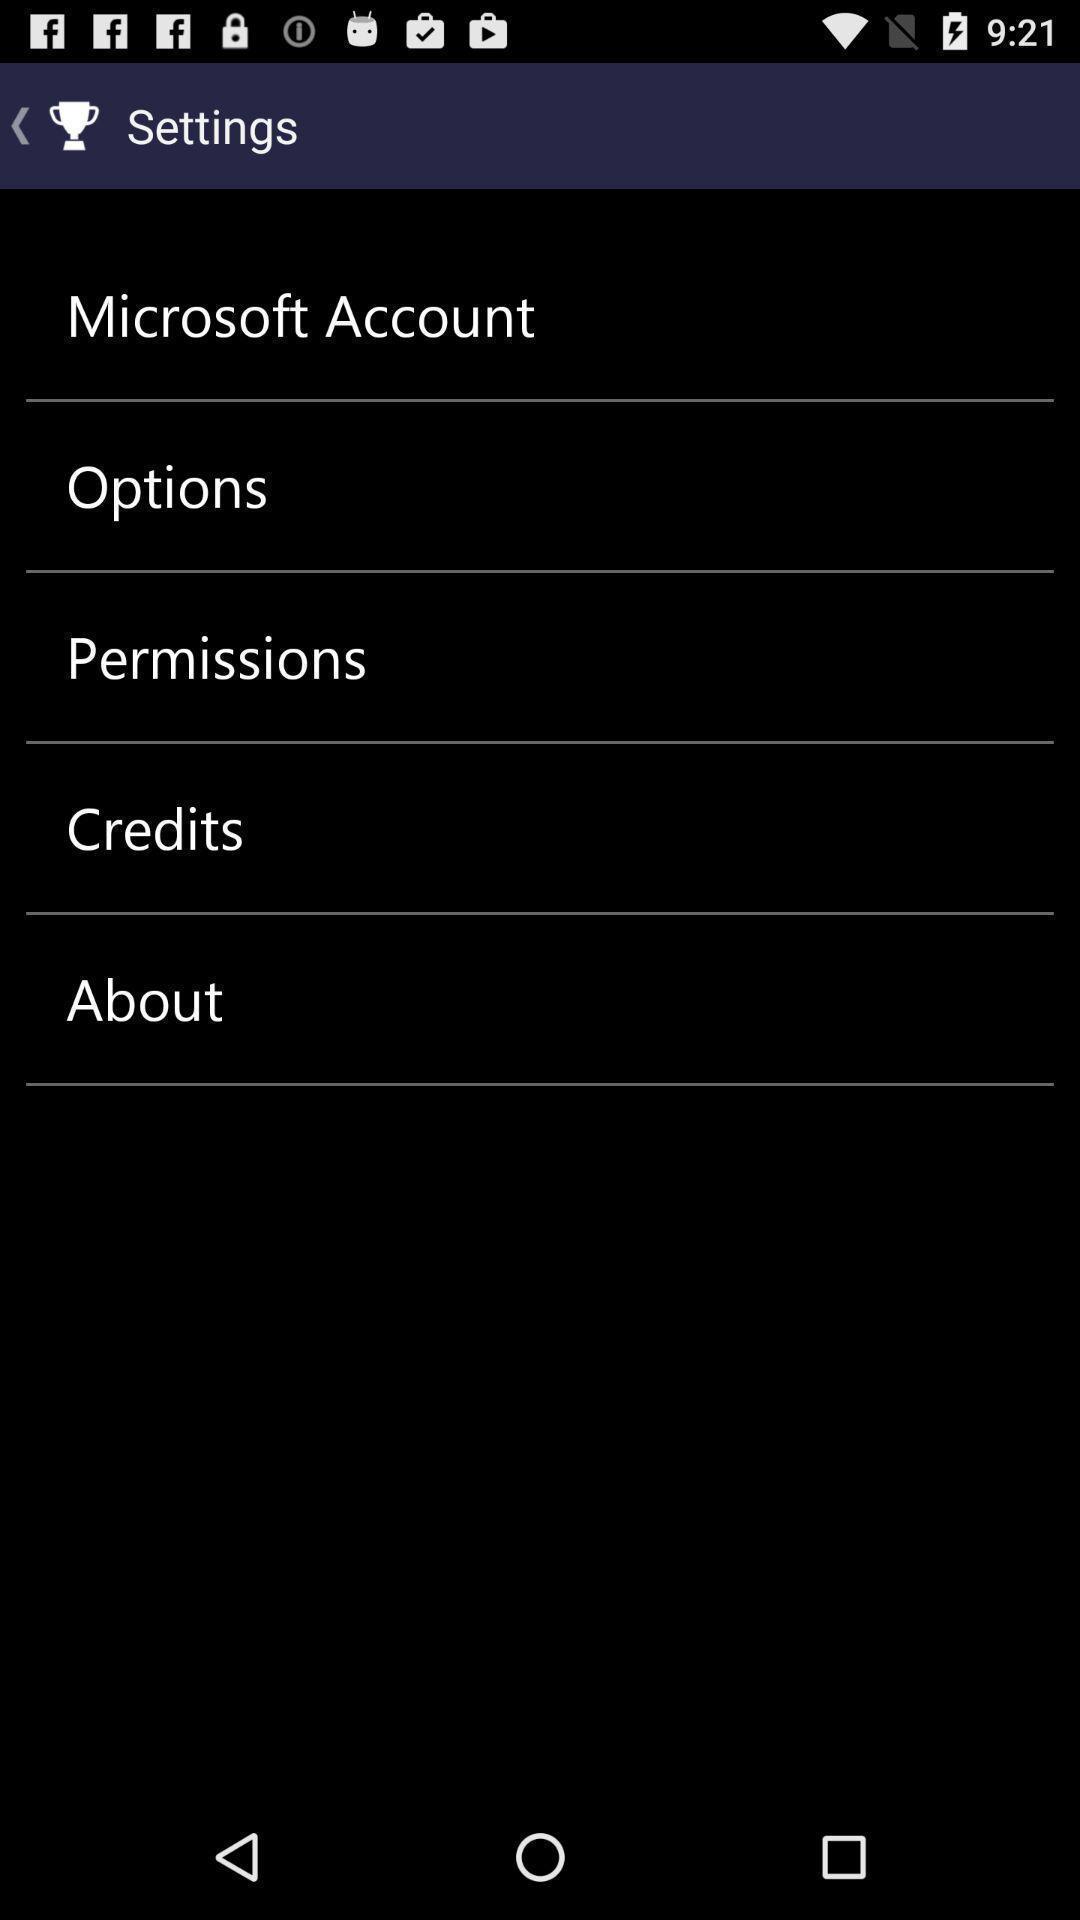Tell me about the visual elements in this screen capture. Settings page. 